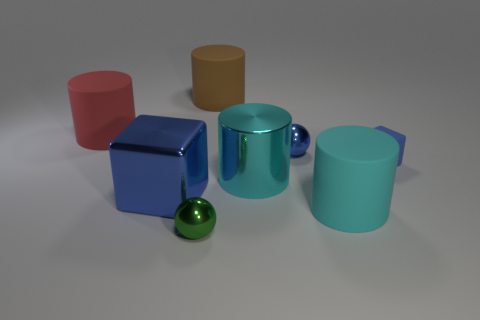What materials seem to be represented by the objects in the image? The objects appear to have surfaces that suggest a variety of materials. The blue and red objects might be plastic due to their matte finish, while the green cylindrical object has a reflective surface, suggesting a metallic finish. The small green sphere could be glass or plastic due to its translucency and high gloss. 